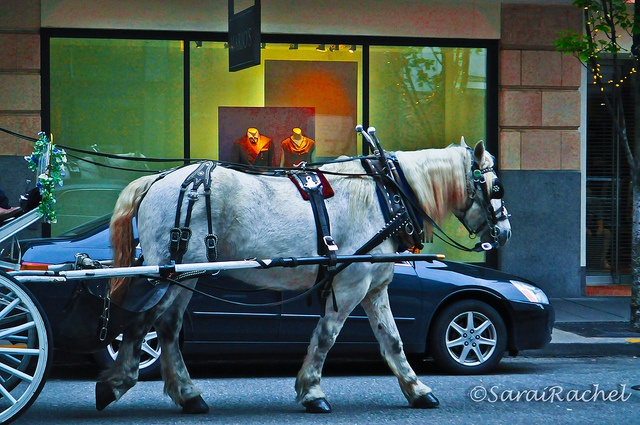Describe the objects in this image and their specific colors. I can see horse in black, gray, lightgray, and blue tones and car in black, navy, lightblue, and blue tones in this image. 